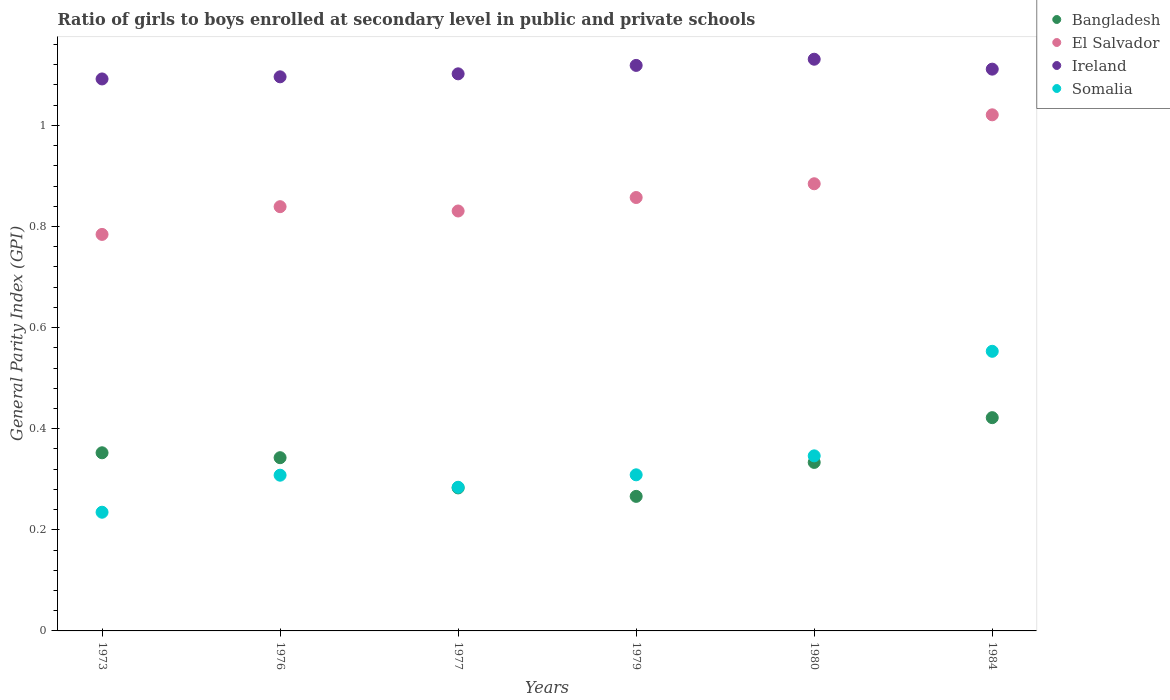Is the number of dotlines equal to the number of legend labels?
Your answer should be compact. Yes. What is the general parity index in El Salvador in 1973?
Your answer should be compact. 0.78. Across all years, what is the maximum general parity index in El Salvador?
Your answer should be compact. 1.02. Across all years, what is the minimum general parity index in Bangladesh?
Ensure brevity in your answer.  0.27. What is the total general parity index in Bangladesh in the graph?
Ensure brevity in your answer.  2. What is the difference between the general parity index in El Salvador in 1980 and that in 1984?
Your response must be concise. -0.14. What is the difference between the general parity index in Ireland in 1984 and the general parity index in Bangladesh in 1977?
Your response must be concise. 0.83. What is the average general parity index in Somalia per year?
Your answer should be compact. 0.34. In the year 1977, what is the difference between the general parity index in El Salvador and general parity index in Bangladesh?
Ensure brevity in your answer.  0.55. What is the ratio of the general parity index in Bangladesh in 1973 to that in 1980?
Ensure brevity in your answer.  1.06. Is the difference between the general parity index in El Salvador in 1980 and 1984 greater than the difference between the general parity index in Bangladesh in 1980 and 1984?
Provide a short and direct response. No. What is the difference between the highest and the second highest general parity index in Bangladesh?
Provide a succinct answer. 0.07. What is the difference between the highest and the lowest general parity index in Somalia?
Ensure brevity in your answer.  0.32. In how many years, is the general parity index in Somalia greater than the average general parity index in Somalia taken over all years?
Your answer should be very brief. 2. Is the sum of the general parity index in El Salvador in 1979 and 1980 greater than the maximum general parity index in Ireland across all years?
Your response must be concise. Yes. How many dotlines are there?
Offer a very short reply. 4. Does the graph contain grids?
Your answer should be very brief. No. How many legend labels are there?
Your response must be concise. 4. What is the title of the graph?
Your answer should be compact. Ratio of girls to boys enrolled at secondary level in public and private schools. What is the label or title of the Y-axis?
Give a very brief answer. General Parity Index (GPI). What is the General Parity Index (GPI) in Bangladesh in 1973?
Ensure brevity in your answer.  0.35. What is the General Parity Index (GPI) in El Salvador in 1973?
Provide a short and direct response. 0.78. What is the General Parity Index (GPI) of Ireland in 1973?
Your response must be concise. 1.09. What is the General Parity Index (GPI) in Somalia in 1973?
Keep it short and to the point. 0.23. What is the General Parity Index (GPI) in Bangladesh in 1976?
Keep it short and to the point. 0.34. What is the General Parity Index (GPI) of El Salvador in 1976?
Ensure brevity in your answer.  0.84. What is the General Parity Index (GPI) in Ireland in 1976?
Provide a succinct answer. 1.1. What is the General Parity Index (GPI) of Somalia in 1976?
Give a very brief answer. 0.31. What is the General Parity Index (GPI) of Bangladesh in 1977?
Make the answer very short. 0.28. What is the General Parity Index (GPI) of El Salvador in 1977?
Provide a succinct answer. 0.83. What is the General Parity Index (GPI) of Ireland in 1977?
Ensure brevity in your answer.  1.1. What is the General Parity Index (GPI) in Somalia in 1977?
Make the answer very short. 0.28. What is the General Parity Index (GPI) of Bangladesh in 1979?
Your answer should be very brief. 0.27. What is the General Parity Index (GPI) in El Salvador in 1979?
Your answer should be compact. 0.86. What is the General Parity Index (GPI) of Ireland in 1979?
Provide a succinct answer. 1.12. What is the General Parity Index (GPI) of Somalia in 1979?
Offer a very short reply. 0.31. What is the General Parity Index (GPI) in Bangladesh in 1980?
Give a very brief answer. 0.33. What is the General Parity Index (GPI) in El Salvador in 1980?
Provide a succinct answer. 0.88. What is the General Parity Index (GPI) of Ireland in 1980?
Offer a very short reply. 1.13. What is the General Parity Index (GPI) in Somalia in 1980?
Offer a terse response. 0.35. What is the General Parity Index (GPI) in Bangladesh in 1984?
Give a very brief answer. 0.42. What is the General Parity Index (GPI) of El Salvador in 1984?
Make the answer very short. 1.02. What is the General Parity Index (GPI) in Ireland in 1984?
Offer a terse response. 1.11. What is the General Parity Index (GPI) of Somalia in 1984?
Offer a terse response. 0.55. Across all years, what is the maximum General Parity Index (GPI) in Bangladesh?
Provide a short and direct response. 0.42. Across all years, what is the maximum General Parity Index (GPI) in El Salvador?
Ensure brevity in your answer.  1.02. Across all years, what is the maximum General Parity Index (GPI) of Ireland?
Give a very brief answer. 1.13. Across all years, what is the maximum General Parity Index (GPI) in Somalia?
Give a very brief answer. 0.55. Across all years, what is the minimum General Parity Index (GPI) of Bangladesh?
Make the answer very short. 0.27. Across all years, what is the minimum General Parity Index (GPI) in El Salvador?
Give a very brief answer. 0.78. Across all years, what is the minimum General Parity Index (GPI) in Ireland?
Offer a very short reply. 1.09. Across all years, what is the minimum General Parity Index (GPI) in Somalia?
Your answer should be very brief. 0.23. What is the total General Parity Index (GPI) in Bangladesh in the graph?
Give a very brief answer. 2. What is the total General Parity Index (GPI) of El Salvador in the graph?
Offer a very short reply. 5.22. What is the total General Parity Index (GPI) of Ireland in the graph?
Make the answer very short. 6.65. What is the total General Parity Index (GPI) of Somalia in the graph?
Provide a short and direct response. 2.04. What is the difference between the General Parity Index (GPI) of Bangladesh in 1973 and that in 1976?
Offer a terse response. 0.01. What is the difference between the General Parity Index (GPI) in El Salvador in 1973 and that in 1976?
Keep it short and to the point. -0.05. What is the difference between the General Parity Index (GPI) of Ireland in 1973 and that in 1976?
Keep it short and to the point. -0. What is the difference between the General Parity Index (GPI) of Somalia in 1973 and that in 1976?
Your answer should be very brief. -0.07. What is the difference between the General Parity Index (GPI) in Bangladesh in 1973 and that in 1977?
Your response must be concise. 0.07. What is the difference between the General Parity Index (GPI) in El Salvador in 1973 and that in 1977?
Your answer should be compact. -0.05. What is the difference between the General Parity Index (GPI) in Ireland in 1973 and that in 1977?
Your answer should be very brief. -0.01. What is the difference between the General Parity Index (GPI) of Somalia in 1973 and that in 1977?
Ensure brevity in your answer.  -0.05. What is the difference between the General Parity Index (GPI) of Bangladesh in 1973 and that in 1979?
Keep it short and to the point. 0.09. What is the difference between the General Parity Index (GPI) in El Salvador in 1973 and that in 1979?
Offer a terse response. -0.07. What is the difference between the General Parity Index (GPI) in Ireland in 1973 and that in 1979?
Make the answer very short. -0.03. What is the difference between the General Parity Index (GPI) in Somalia in 1973 and that in 1979?
Make the answer very short. -0.07. What is the difference between the General Parity Index (GPI) in Bangladesh in 1973 and that in 1980?
Make the answer very short. 0.02. What is the difference between the General Parity Index (GPI) in El Salvador in 1973 and that in 1980?
Keep it short and to the point. -0.1. What is the difference between the General Parity Index (GPI) of Ireland in 1973 and that in 1980?
Provide a short and direct response. -0.04. What is the difference between the General Parity Index (GPI) in Somalia in 1973 and that in 1980?
Offer a terse response. -0.11. What is the difference between the General Parity Index (GPI) in Bangladesh in 1973 and that in 1984?
Keep it short and to the point. -0.07. What is the difference between the General Parity Index (GPI) in El Salvador in 1973 and that in 1984?
Your response must be concise. -0.24. What is the difference between the General Parity Index (GPI) of Ireland in 1973 and that in 1984?
Offer a terse response. -0.02. What is the difference between the General Parity Index (GPI) in Somalia in 1973 and that in 1984?
Keep it short and to the point. -0.32. What is the difference between the General Parity Index (GPI) in Bangladesh in 1976 and that in 1977?
Make the answer very short. 0.06. What is the difference between the General Parity Index (GPI) of El Salvador in 1976 and that in 1977?
Give a very brief answer. 0.01. What is the difference between the General Parity Index (GPI) in Ireland in 1976 and that in 1977?
Provide a succinct answer. -0.01. What is the difference between the General Parity Index (GPI) in Somalia in 1976 and that in 1977?
Keep it short and to the point. 0.02. What is the difference between the General Parity Index (GPI) in Bangladesh in 1976 and that in 1979?
Offer a very short reply. 0.08. What is the difference between the General Parity Index (GPI) of El Salvador in 1976 and that in 1979?
Keep it short and to the point. -0.02. What is the difference between the General Parity Index (GPI) in Ireland in 1976 and that in 1979?
Provide a short and direct response. -0.02. What is the difference between the General Parity Index (GPI) of Somalia in 1976 and that in 1979?
Offer a terse response. -0. What is the difference between the General Parity Index (GPI) of Bangladesh in 1976 and that in 1980?
Your answer should be compact. 0.01. What is the difference between the General Parity Index (GPI) of El Salvador in 1976 and that in 1980?
Your response must be concise. -0.05. What is the difference between the General Parity Index (GPI) of Ireland in 1976 and that in 1980?
Make the answer very short. -0.03. What is the difference between the General Parity Index (GPI) in Somalia in 1976 and that in 1980?
Make the answer very short. -0.04. What is the difference between the General Parity Index (GPI) in Bangladesh in 1976 and that in 1984?
Make the answer very short. -0.08. What is the difference between the General Parity Index (GPI) of El Salvador in 1976 and that in 1984?
Your answer should be very brief. -0.18. What is the difference between the General Parity Index (GPI) of Ireland in 1976 and that in 1984?
Provide a short and direct response. -0.02. What is the difference between the General Parity Index (GPI) in Somalia in 1976 and that in 1984?
Your answer should be compact. -0.24. What is the difference between the General Parity Index (GPI) of Bangladesh in 1977 and that in 1979?
Your response must be concise. 0.02. What is the difference between the General Parity Index (GPI) in El Salvador in 1977 and that in 1979?
Provide a short and direct response. -0.03. What is the difference between the General Parity Index (GPI) of Ireland in 1977 and that in 1979?
Your answer should be very brief. -0.02. What is the difference between the General Parity Index (GPI) in Somalia in 1977 and that in 1979?
Provide a short and direct response. -0.02. What is the difference between the General Parity Index (GPI) in Bangladesh in 1977 and that in 1980?
Your answer should be compact. -0.05. What is the difference between the General Parity Index (GPI) in El Salvador in 1977 and that in 1980?
Offer a very short reply. -0.05. What is the difference between the General Parity Index (GPI) in Ireland in 1977 and that in 1980?
Offer a very short reply. -0.03. What is the difference between the General Parity Index (GPI) in Somalia in 1977 and that in 1980?
Give a very brief answer. -0.06. What is the difference between the General Parity Index (GPI) of Bangladesh in 1977 and that in 1984?
Offer a terse response. -0.14. What is the difference between the General Parity Index (GPI) of El Salvador in 1977 and that in 1984?
Ensure brevity in your answer.  -0.19. What is the difference between the General Parity Index (GPI) in Ireland in 1977 and that in 1984?
Your response must be concise. -0.01. What is the difference between the General Parity Index (GPI) of Somalia in 1977 and that in 1984?
Ensure brevity in your answer.  -0.27. What is the difference between the General Parity Index (GPI) of Bangladesh in 1979 and that in 1980?
Your answer should be very brief. -0.07. What is the difference between the General Parity Index (GPI) of El Salvador in 1979 and that in 1980?
Give a very brief answer. -0.03. What is the difference between the General Parity Index (GPI) in Ireland in 1979 and that in 1980?
Keep it short and to the point. -0.01. What is the difference between the General Parity Index (GPI) in Somalia in 1979 and that in 1980?
Your answer should be compact. -0.04. What is the difference between the General Parity Index (GPI) of Bangladesh in 1979 and that in 1984?
Your answer should be compact. -0.16. What is the difference between the General Parity Index (GPI) of El Salvador in 1979 and that in 1984?
Keep it short and to the point. -0.16. What is the difference between the General Parity Index (GPI) of Ireland in 1979 and that in 1984?
Offer a very short reply. 0.01. What is the difference between the General Parity Index (GPI) in Somalia in 1979 and that in 1984?
Give a very brief answer. -0.24. What is the difference between the General Parity Index (GPI) in Bangladesh in 1980 and that in 1984?
Make the answer very short. -0.09. What is the difference between the General Parity Index (GPI) in El Salvador in 1980 and that in 1984?
Provide a short and direct response. -0.14. What is the difference between the General Parity Index (GPI) in Ireland in 1980 and that in 1984?
Make the answer very short. 0.02. What is the difference between the General Parity Index (GPI) in Somalia in 1980 and that in 1984?
Ensure brevity in your answer.  -0.21. What is the difference between the General Parity Index (GPI) of Bangladesh in 1973 and the General Parity Index (GPI) of El Salvador in 1976?
Give a very brief answer. -0.49. What is the difference between the General Parity Index (GPI) of Bangladesh in 1973 and the General Parity Index (GPI) of Ireland in 1976?
Your answer should be compact. -0.74. What is the difference between the General Parity Index (GPI) of Bangladesh in 1973 and the General Parity Index (GPI) of Somalia in 1976?
Your answer should be very brief. 0.04. What is the difference between the General Parity Index (GPI) in El Salvador in 1973 and the General Parity Index (GPI) in Ireland in 1976?
Offer a very short reply. -0.31. What is the difference between the General Parity Index (GPI) of El Salvador in 1973 and the General Parity Index (GPI) of Somalia in 1976?
Ensure brevity in your answer.  0.48. What is the difference between the General Parity Index (GPI) in Ireland in 1973 and the General Parity Index (GPI) in Somalia in 1976?
Your answer should be very brief. 0.78. What is the difference between the General Parity Index (GPI) in Bangladesh in 1973 and the General Parity Index (GPI) in El Salvador in 1977?
Your answer should be very brief. -0.48. What is the difference between the General Parity Index (GPI) in Bangladesh in 1973 and the General Parity Index (GPI) in Ireland in 1977?
Give a very brief answer. -0.75. What is the difference between the General Parity Index (GPI) in Bangladesh in 1973 and the General Parity Index (GPI) in Somalia in 1977?
Your answer should be compact. 0.07. What is the difference between the General Parity Index (GPI) in El Salvador in 1973 and the General Parity Index (GPI) in Ireland in 1977?
Offer a very short reply. -0.32. What is the difference between the General Parity Index (GPI) in El Salvador in 1973 and the General Parity Index (GPI) in Somalia in 1977?
Your response must be concise. 0.5. What is the difference between the General Parity Index (GPI) of Ireland in 1973 and the General Parity Index (GPI) of Somalia in 1977?
Ensure brevity in your answer.  0.81. What is the difference between the General Parity Index (GPI) of Bangladesh in 1973 and the General Parity Index (GPI) of El Salvador in 1979?
Make the answer very short. -0.5. What is the difference between the General Parity Index (GPI) of Bangladesh in 1973 and the General Parity Index (GPI) of Ireland in 1979?
Ensure brevity in your answer.  -0.77. What is the difference between the General Parity Index (GPI) in Bangladesh in 1973 and the General Parity Index (GPI) in Somalia in 1979?
Your answer should be compact. 0.04. What is the difference between the General Parity Index (GPI) in El Salvador in 1973 and the General Parity Index (GPI) in Ireland in 1979?
Provide a succinct answer. -0.33. What is the difference between the General Parity Index (GPI) of El Salvador in 1973 and the General Parity Index (GPI) of Somalia in 1979?
Offer a very short reply. 0.48. What is the difference between the General Parity Index (GPI) of Ireland in 1973 and the General Parity Index (GPI) of Somalia in 1979?
Keep it short and to the point. 0.78. What is the difference between the General Parity Index (GPI) in Bangladesh in 1973 and the General Parity Index (GPI) in El Salvador in 1980?
Offer a terse response. -0.53. What is the difference between the General Parity Index (GPI) in Bangladesh in 1973 and the General Parity Index (GPI) in Ireland in 1980?
Ensure brevity in your answer.  -0.78. What is the difference between the General Parity Index (GPI) of Bangladesh in 1973 and the General Parity Index (GPI) of Somalia in 1980?
Make the answer very short. 0.01. What is the difference between the General Parity Index (GPI) in El Salvador in 1973 and the General Parity Index (GPI) in Ireland in 1980?
Provide a succinct answer. -0.35. What is the difference between the General Parity Index (GPI) of El Salvador in 1973 and the General Parity Index (GPI) of Somalia in 1980?
Make the answer very short. 0.44. What is the difference between the General Parity Index (GPI) in Ireland in 1973 and the General Parity Index (GPI) in Somalia in 1980?
Your answer should be very brief. 0.75. What is the difference between the General Parity Index (GPI) of Bangladesh in 1973 and the General Parity Index (GPI) of El Salvador in 1984?
Ensure brevity in your answer.  -0.67. What is the difference between the General Parity Index (GPI) in Bangladesh in 1973 and the General Parity Index (GPI) in Ireland in 1984?
Your response must be concise. -0.76. What is the difference between the General Parity Index (GPI) in Bangladesh in 1973 and the General Parity Index (GPI) in Somalia in 1984?
Offer a very short reply. -0.2. What is the difference between the General Parity Index (GPI) of El Salvador in 1973 and the General Parity Index (GPI) of Ireland in 1984?
Your answer should be very brief. -0.33. What is the difference between the General Parity Index (GPI) of El Salvador in 1973 and the General Parity Index (GPI) of Somalia in 1984?
Ensure brevity in your answer.  0.23. What is the difference between the General Parity Index (GPI) of Ireland in 1973 and the General Parity Index (GPI) of Somalia in 1984?
Provide a succinct answer. 0.54. What is the difference between the General Parity Index (GPI) of Bangladesh in 1976 and the General Parity Index (GPI) of El Salvador in 1977?
Ensure brevity in your answer.  -0.49. What is the difference between the General Parity Index (GPI) of Bangladesh in 1976 and the General Parity Index (GPI) of Ireland in 1977?
Your answer should be compact. -0.76. What is the difference between the General Parity Index (GPI) in Bangladesh in 1976 and the General Parity Index (GPI) in Somalia in 1977?
Provide a short and direct response. 0.06. What is the difference between the General Parity Index (GPI) of El Salvador in 1976 and the General Parity Index (GPI) of Ireland in 1977?
Offer a very short reply. -0.26. What is the difference between the General Parity Index (GPI) of El Salvador in 1976 and the General Parity Index (GPI) of Somalia in 1977?
Keep it short and to the point. 0.56. What is the difference between the General Parity Index (GPI) in Ireland in 1976 and the General Parity Index (GPI) in Somalia in 1977?
Make the answer very short. 0.81. What is the difference between the General Parity Index (GPI) in Bangladesh in 1976 and the General Parity Index (GPI) in El Salvador in 1979?
Give a very brief answer. -0.51. What is the difference between the General Parity Index (GPI) of Bangladesh in 1976 and the General Parity Index (GPI) of Ireland in 1979?
Give a very brief answer. -0.78. What is the difference between the General Parity Index (GPI) in Bangladesh in 1976 and the General Parity Index (GPI) in Somalia in 1979?
Ensure brevity in your answer.  0.03. What is the difference between the General Parity Index (GPI) in El Salvador in 1976 and the General Parity Index (GPI) in Ireland in 1979?
Ensure brevity in your answer.  -0.28. What is the difference between the General Parity Index (GPI) in El Salvador in 1976 and the General Parity Index (GPI) in Somalia in 1979?
Offer a very short reply. 0.53. What is the difference between the General Parity Index (GPI) in Ireland in 1976 and the General Parity Index (GPI) in Somalia in 1979?
Make the answer very short. 0.79. What is the difference between the General Parity Index (GPI) in Bangladesh in 1976 and the General Parity Index (GPI) in El Salvador in 1980?
Your response must be concise. -0.54. What is the difference between the General Parity Index (GPI) in Bangladesh in 1976 and the General Parity Index (GPI) in Ireland in 1980?
Offer a very short reply. -0.79. What is the difference between the General Parity Index (GPI) of Bangladesh in 1976 and the General Parity Index (GPI) of Somalia in 1980?
Give a very brief answer. -0. What is the difference between the General Parity Index (GPI) of El Salvador in 1976 and the General Parity Index (GPI) of Ireland in 1980?
Make the answer very short. -0.29. What is the difference between the General Parity Index (GPI) in El Salvador in 1976 and the General Parity Index (GPI) in Somalia in 1980?
Make the answer very short. 0.49. What is the difference between the General Parity Index (GPI) in Ireland in 1976 and the General Parity Index (GPI) in Somalia in 1980?
Your response must be concise. 0.75. What is the difference between the General Parity Index (GPI) in Bangladesh in 1976 and the General Parity Index (GPI) in El Salvador in 1984?
Provide a succinct answer. -0.68. What is the difference between the General Parity Index (GPI) of Bangladesh in 1976 and the General Parity Index (GPI) of Ireland in 1984?
Provide a short and direct response. -0.77. What is the difference between the General Parity Index (GPI) of Bangladesh in 1976 and the General Parity Index (GPI) of Somalia in 1984?
Offer a terse response. -0.21. What is the difference between the General Parity Index (GPI) of El Salvador in 1976 and the General Parity Index (GPI) of Ireland in 1984?
Your answer should be very brief. -0.27. What is the difference between the General Parity Index (GPI) in El Salvador in 1976 and the General Parity Index (GPI) in Somalia in 1984?
Offer a very short reply. 0.29. What is the difference between the General Parity Index (GPI) of Ireland in 1976 and the General Parity Index (GPI) of Somalia in 1984?
Your answer should be compact. 0.54. What is the difference between the General Parity Index (GPI) in Bangladesh in 1977 and the General Parity Index (GPI) in El Salvador in 1979?
Your response must be concise. -0.57. What is the difference between the General Parity Index (GPI) in Bangladesh in 1977 and the General Parity Index (GPI) in Ireland in 1979?
Your answer should be very brief. -0.84. What is the difference between the General Parity Index (GPI) in Bangladesh in 1977 and the General Parity Index (GPI) in Somalia in 1979?
Ensure brevity in your answer.  -0.03. What is the difference between the General Parity Index (GPI) in El Salvador in 1977 and the General Parity Index (GPI) in Ireland in 1979?
Make the answer very short. -0.29. What is the difference between the General Parity Index (GPI) in El Salvador in 1977 and the General Parity Index (GPI) in Somalia in 1979?
Give a very brief answer. 0.52. What is the difference between the General Parity Index (GPI) of Ireland in 1977 and the General Parity Index (GPI) of Somalia in 1979?
Make the answer very short. 0.79. What is the difference between the General Parity Index (GPI) of Bangladesh in 1977 and the General Parity Index (GPI) of El Salvador in 1980?
Keep it short and to the point. -0.6. What is the difference between the General Parity Index (GPI) in Bangladesh in 1977 and the General Parity Index (GPI) in Ireland in 1980?
Provide a short and direct response. -0.85. What is the difference between the General Parity Index (GPI) of Bangladesh in 1977 and the General Parity Index (GPI) of Somalia in 1980?
Your answer should be very brief. -0.06. What is the difference between the General Parity Index (GPI) in El Salvador in 1977 and the General Parity Index (GPI) in Ireland in 1980?
Your answer should be compact. -0.3. What is the difference between the General Parity Index (GPI) in El Salvador in 1977 and the General Parity Index (GPI) in Somalia in 1980?
Offer a terse response. 0.48. What is the difference between the General Parity Index (GPI) in Ireland in 1977 and the General Parity Index (GPI) in Somalia in 1980?
Offer a very short reply. 0.76. What is the difference between the General Parity Index (GPI) of Bangladesh in 1977 and the General Parity Index (GPI) of El Salvador in 1984?
Offer a terse response. -0.74. What is the difference between the General Parity Index (GPI) of Bangladesh in 1977 and the General Parity Index (GPI) of Ireland in 1984?
Your response must be concise. -0.83. What is the difference between the General Parity Index (GPI) in Bangladesh in 1977 and the General Parity Index (GPI) in Somalia in 1984?
Offer a terse response. -0.27. What is the difference between the General Parity Index (GPI) of El Salvador in 1977 and the General Parity Index (GPI) of Ireland in 1984?
Make the answer very short. -0.28. What is the difference between the General Parity Index (GPI) in El Salvador in 1977 and the General Parity Index (GPI) in Somalia in 1984?
Your response must be concise. 0.28. What is the difference between the General Parity Index (GPI) of Ireland in 1977 and the General Parity Index (GPI) of Somalia in 1984?
Offer a very short reply. 0.55. What is the difference between the General Parity Index (GPI) in Bangladesh in 1979 and the General Parity Index (GPI) in El Salvador in 1980?
Make the answer very short. -0.62. What is the difference between the General Parity Index (GPI) in Bangladesh in 1979 and the General Parity Index (GPI) in Ireland in 1980?
Provide a short and direct response. -0.86. What is the difference between the General Parity Index (GPI) in Bangladesh in 1979 and the General Parity Index (GPI) in Somalia in 1980?
Offer a terse response. -0.08. What is the difference between the General Parity Index (GPI) of El Salvador in 1979 and the General Parity Index (GPI) of Ireland in 1980?
Your answer should be very brief. -0.27. What is the difference between the General Parity Index (GPI) of El Salvador in 1979 and the General Parity Index (GPI) of Somalia in 1980?
Give a very brief answer. 0.51. What is the difference between the General Parity Index (GPI) in Ireland in 1979 and the General Parity Index (GPI) in Somalia in 1980?
Make the answer very short. 0.77. What is the difference between the General Parity Index (GPI) of Bangladesh in 1979 and the General Parity Index (GPI) of El Salvador in 1984?
Your response must be concise. -0.75. What is the difference between the General Parity Index (GPI) of Bangladesh in 1979 and the General Parity Index (GPI) of Ireland in 1984?
Provide a short and direct response. -0.84. What is the difference between the General Parity Index (GPI) of Bangladesh in 1979 and the General Parity Index (GPI) of Somalia in 1984?
Give a very brief answer. -0.29. What is the difference between the General Parity Index (GPI) in El Salvador in 1979 and the General Parity Index (GPI) in Ireland in 1984?
Your answer should be very brief. -0.25. What is the difference between the General Parity Index (GPI) in El Salvador in 1979 and the General Parity Index (GPI) in Somalia in 1984?
Provide a short and direct response. 0.3. What is the difference between the General Parity Index (GPI) in Ireland in 1979 and the General Parity Index (GPI) in Somalia in 1984?
Make the answer very short. 0.57. What is the difference between the General Parity Index (GPI) in Bangladesh in 1980 and the General Parity Index (GPI) in El Salvador in 1984?
Your response must be concise. -0.69. What is the difference between the General Parity Index (GPI) in Bangladesh in 1980 and the General Parity Index (GPI) in Ireland in 1984?
Your response must be concise. -0.78. What is the difference between the General Parity Index (GPI) of Bangladesh in 1980 and the General Parity Index (GPI) of Somalia in 1984?
Your answer should be compact. -0.22. What is the difference between the General Parity Index (GPI) in El Salvador in 1980 and the General Parity Index (GPI) in Ireland in 1984?
Your response must be concise. -0.23. What is the difference between the General Parity Index (GPI) of El Salvador in 1980 and the General Parity Index (GPI) of Somalia in 1984?
Give a very brief answer. 0.33. What is the difference between the General Parity Index (GPI) of Ireland in 1980 and the General Parity Index (GPI) of Somalia in 1984?
Make the answer very short. 0.58. What is the average General Parity Index (GPI) of Bangladesh per year?
Give a very brief answer. 0.33. What is the average General Parity Index (GPI) of El Salvador per year?
Your answer should be very brief. 0.87. What is the average General Parity Index (GPI) of Ireland per year?
Make the answer very short. 1.11. What is the average General Parity Index (GPI) of Somalia per year?
Your answer should be compact. 0.34. In the year 1973, what is the difference between the General Parity Index (GPI) of Bangladesh and General Parity Index (GPI) of El Salvador?
Keep it short and to the point. -0.43. In the year 1973, what is the difference between the General Parity Index (GPI) of Bangladesh and General Parity Index (GPI) of Ireland?
Make the answer very short. -0.74. In the year 1973, what is the difference between the General Parity Index (GPI) in Bangladesh and General Parity Index (GPI) in Somalia?
Offer a terse response. 0.12. In the year 1973, what is the difference between the General Parity Index (GPI) of El Salvador and General Parity Index (GPI) of Ireland?
Your response must be concise. -0.31. In the year 1973, what is the difference between the General Parity Index (GPI) in El Salvador and General Parity Index (GPI) in Somalia?
Keep it short and to the point. 0.55. In the year 1973, what is the difference between the General Parity Index (GPI) in Ireland and General Parity Index (GPI) in Somalia?
Give a very brief answer. 0.86. In the year 1976, what is the difference between the General Parity Index (GPI) of Bangladesh and General Parity Index (GPI) of El Salvador?
Your answer should be compact. -0.5. In the year 1976, what is the difference between the General Parity Index (GPI) of Bangladesh and General Parity Index (GPI) of Ireland?
Ensure brevity in your answer.  -0.75. In the year 1976, what is the difference between the General Parity Index (GPI) in Bangladesh and General Parity Index (GPI) in Somalia?
Keep it short and to the point. 0.03. In the year 1976, what is the difference between the General Parity Index (GPI) of El Salvador and General Parity Index (GPI) of Ireland?
Your answer should be very brief. -0.26. In the year 1976, what is the difference between the General Parity Index (GPI) in El Salvador and General Parity Index (GPI) in Somalia?
Your answer should be compact. 0.53. In the year 1976, what is the difference between the General Parity Index (GPI) of Ireland and General Parity Index (GPI) of Somalia?
Make the answer very short. 0.79. In the year 1977, what is the difference between the General Parity Index (GPI) in Bangladesh and General Parity Index (GPI) in El Salvador?
Your answer should be compact. -0.55. In the year 1977, what is the difference between the General Parity Index (GPI) of Bangladesh and General Parity Index (GPI) of Ireland?
Keep it short and to the point. -0.82. In the year 1977, what is the difference between the General Parity Index (GPI) of Bangladesh and General Parity Index (GPI) of Somalia?
Your answer should be very brief. -0. In the year 1977, what is the difference between the General Parity Index (GPI) of El Salvador and General Parity Index (GPI) of Ireland?
Offer a terse response. -0.27. In the year 1977, what is the difference between the General Parity Index (GPI) of El Salvador and General Parity Index (GPI) of Somalia?
Give a very brief answer. 0.55. In the year 1977, what is the difference between the General Parity Index (GPI) in Ireland and General Parity Index (GPI) in Somalia?
Make the answer very short. 0.82. In the year 1979, what is the difference between the General Parity Index (GPI) in Bangladesh and General Parity Index (GPI) in El Salvador?
Your response must be concise. -0.59. In the year 1979, what is the difference between the General Parity Index (GPI) in Bangladesh and General Parity Index (GPI) in Ireland?
Make the answer very short. -0.85. In the year 1979, what is the difference between the General Parity Index (GPI) in Bangladesh and General Parity Index (GPI) in Somalia?
Keep it short and to the point. -0.04. In the year 1979, what is the difference between the General Parity Index (GPI) in El Salvador and General Parity Index (GPI) in Ireland?
Your answer should be compact. -0.26. In the year 1979, what is the difference between the General Parity Index (GPI) of El Salvador and General Parity Index (GPI) of Somalia?
Provide a succinct answer. 0.55. In the year 1979, what is the difference between the General Parity Index (GPI) of Ireland and General Parity Index (GPI) of Somalia?
Offer a terse response. 0.81. In the year 1980, what is the difference between the General Parity Index (GPI) of Bangladesh and General Parity Index (GPI) of El Salvador?
Make the answer very short. -0.55. In the year 1980, what is the difference between the General Parity Index (GPI) of Bangladesh and General Parity Index (GPI) of Ireland?
Your response must be concise. -0.8. In the year 1980, what is the difference between the General Parity Index (GPI) in Bangladesh and General Parity Index (GPI) in Somalia?
Your response must be concise. -0.01. In the year 1980, what is the difference between the General Parity Index (GPI) in El Salvador and General Parity Index (GPI) in Ireland?
Make the answer very short. -0.25. In the year 1980, what is the difference between the General Parity Index (GPI) in El Salvador and General Parity Index (GPI) in Somalia?
Offer a very short reply. 0.54. In the year 1980, what is the difference between the General Parity Index (GPI) of Ireland and General Parity Index (GPI) of Somalia?
Give a very brief answer. 0.78. In the year 1984, what is the difference between the General Parity Index (GPI) in Bangladesh and General Parity Index (GPI) in El Salvador?
Your answer should be very brief. -0.6. In the year 1984, what is the difference between the General Parity Index (GPI) in Bangladesh and General Parity Index (GPI) in Ireland?
Ensure brevity in your answer.  -0.69. In the year 1984, what is the difference between the General Parity Index (GPI) in Bangladesh and General Parity Index (GPI) in Somalia?
Provide a succinct answer. -0.13. In the year 1984, what is the difference between the General Parity Index (GPI) in El Salvador and General Parity Index (GPI) in Ireland?
Offer a very short reply. -0.09. In the year 1984, what is the difference between the General Parity Index (GPI) in El Salvador and General Parity Index (GPI) in Somalia?
Your response must be concise. 0.47. In the year 1984, what is the difference between the General Parity Index (GPI) in Ireland and General Parity Index (GPI) in Somalia?
Your answer should be very brief. 0.56. What is the ratio of the General Parity Index (GPI) of Bangladesh in 1973 to that in 1976?
Keep it short and to the point. 1.03. What is the ratio of the General Parity Index (GPI) in El Salvador in 1973 to that in 1976?
Your answer should be compact. 0.93. What is the ratio of the General Parity Index (GPI) of Somalia in 1973 to that in 1976?
Provide a succinct answer. 0.76. What is the ratio of the General Parity Index (GPI) in Bangladesh in 1973 to that in 1977?
Ensure brevity in your answer.  1.25. What is the ratio of the General Parity Index (GPI) in El Salvador in 1973 to that in 1977?
Keep it short and to the point. 0.94. What is the ratio of the General Parity Index (GPI) of Somalia in 1973 to that in 1977?
Your answer should be very brief. 0.83. What is the ratio of the General Parity Index (GPI) in Bangladesh in 1973 to that in 1979?
Offer a terse response. 1.32. What is the ratio of the General Parity Index (GPI) in El Salvador in 1973 to that in 1979?
Ensure brevity in your answer.  0.91. What is the ratio of the General Parity Index (GPI) in Ireland in 1973 to that in 1979?
Offer a very short reply. 0.98. What is the ratio of the General Parity Index (GPI) in Somalia in 1973 to that in 1979?
Your response must be concise. 0.76. What is the ratio of the General Parity Index (GPI) in Bangladesh in 1973 to that in 1980?
Provide a succinct answer. 1.06. What is the ratio of the General Parity Index (GPI) of El Salvador in 1973 to that in 1980?
Make the answer very short. 0.89. What is the ratio of the General Parity Index (GPI) of Ireland in 1973 to that in 1980?
Make the answer very short. 0.97. What is the ratio of the General Parity Index (GPI) in Somalia in 1973 to that in 1980?
Your answer should be compact. 0.68. What is the ratio of the General Parity Index (GPI) of Bangladesh in 1973 to that in 1984?
Your answer should be very brief. 0.84. What is the ratio of the General Parity Index (GPI) of El Salvador in 1973 to that in 1984?
Your answer should be very brief. 0.77. What is the ratio of the General Parity Index (GPI) of Ireland in 1973 to that in 1984?
Your answer should be very brief. 0.98. What is the ratio of the General Parity Index (GPI) of Somalia in 1973 to that in 1984?
Provide a short and direct response. 0.42. What is the ratio of the General Parity Index (GPI) in Bangladesh in 1976 to that in 1977?
Ensure brevity in your answer.  1.21. What is the ratio of the General Parity Index (GPI) of El Salvador in 1976 to that in 1977?
Offer a terse response. 1.01. What is the ratio of the General Parity Index (GPI) of Somalia in 1976 to that in 1977?
Your answer should be very brief. 1.08. What is the ratio of the General Parity Index (GPI) in Bangladesh in 1976 to that in 1979?
Your response must be concise. 1.29. What is the ratio of the General Parity Index (GPI) of El Salvador in 1976 to that in 1979?
Your answer should be very brief. 0.98. What is the ratio of the General Parity Index (GPI) of Ireland in 1976 to that in 1979?
Ensure brevity in your answer.  0.98. What is the ratio of the General Parity Index (GPI) of Somalia in 1976 to that in 1979?
Make the answer very short. 1. What is the ratio of the General Parity Index (GPI) of Bangladesh in 1976 to that in 1980?
Provide a succinct answer. 1.03. What is the ratio of the General Parity Index (GPI) in El Salvador in 1976 to that in 1980?
Make the answer very short. 0.95. What is the ratio of the General Parity Index (GPI) of Ireland in 1976 to that in 1980?
Ensure brevity in your answer.  0.97. What is the ratio of the General Parity Index (GPI) in Somalia in 1976 to that in 1980?
Your response must be concise. 0.89. What is the ratio of the General Parity Index (GPI) in Bangladesh in 1976 to that in 1984?
Your answer should be compact. 0.81. What is the ratio of the General Parity Index (GPI) in El Salvador in 1976 to that in 1984?
Offer a very short reply. 0.82. What is the ratio of the General Parity Index (GPI) of Ireland in 1976 to that in 1984?
Keep it short and to the point. 0.99. What is the ratio of the General Parity Index (GPI) of Somalia in 1976 to that in 1984?
Your answer should be compact. 0.56. What is the ratio of the General Parity Index (GPI) of Bangladesh in 1977 to that in 1979?
Your answer should be compact. 1.06. What is the ratio of the General Parity Index (GPI) of El Salvador in 1977 to that in 1979?
Your answer should be very brief. 0.97. What is the ratio of the General Parity Index (GPI) in Ireland in 1977 to that in 1979?
Offer a very short reply. 0.99. What is the ratio of the General Parity Index (GPI) of Somalia in 1977 to that in 1979?
Give a very brief answer. 0.92. What is the ratio of the General Parity Index (GPI) in Bangladesh in 1977 to that in 1980?
Ensure brevity in your answer.  0.85. What is the ratio of the General Parity Index (GPI) of El Salvador in 1977 to that in 1980?
Make the answer very short. 0.94. What is the ratio of the General Parity Index (GPI) of Ireland in 1977 to that in 1980?
Your answer should be compact. 0.97. What is the ratio of the General Parity Index (GPI) in Somalia in 1977 to that in 1980?
Make the answer very short. 0.82. What is the ratio of the General Parity Index (GPI) of Bangladesh in 1977 to that in 1984?
Provide a short and direct response. 0.67. What is the ratio of the General Parity Index (GPI) of El Salvador in 1977 to that in 1984?
Provide a succinct answer. 0.81. What is the ratio of the General Parity Index (GPI) of Somalia in 1977 to that in 1984?
Give a very brief answer. 0.51. What is the ratio of the General Parity Index (GPI) of Bangladesh in 1979 to that in 1980?
Your answer should be compact. 0.8. What is the ratio of the General Parity Index (GPI) of El Salvador in 1979 to that in 1980?
Offer a terse response. 0.97. What is the ratio of the General Parity Index (GPI) in Ireland in 1979 to that in 1980?
Keep it short and to the point. 0.99. What is the ratio of the General Parity Index (GPI) of Somalia in 1979 to that in 1980?
Provide a succinct answer. 0.89. What is the ratio of the General Parity Index (GPI) of Bangladesh in 1979 to that in 1984?
Ensure brevity in your answer.  0.63. What is the ratio of the General Parity Index (GPI) of El Salvador in 1979 to that in 1984?
Provide a succinct answer. 0.84. What is the ratio of the General Parity Index (GPI) of Somalia in 1979 to that in 1984?
Your answer should be compact. 0.56. What is the ratio of the General Parity Index (GPI) in Bangladesh in 1980 to that in 1984?
Your answer should be very brief. 0.79. What is the ratio of the General Parity Index (GPI) of El Salvador in 1980 to that in 1984?
Make the answer very short. 0.87. What is the ratio of the General Parity Index (GPI) in Ireland in 1980 to that in 1984?
Your answer should be compact. 1.02. What is the ratio of the General Parity Index (GPI) in Somalia in 1980 to that in 1984?
Provide a succinct answer. 0.63. What is the difference between the highest and the second highest General Parity Index (GPI) in Bangladesh?
Your answer should be compact. 0.07. What is the difference between the highest and the second highest General Parity Index (GPI) in El Salvador?
Ensure brevity in your answer.  0.14. What is the difference between the highest and the second highest General Parity Index (GPI) in Ireland?
Your answer should be very brief. 0.01. What is the difference between the highest and the second highest General Parity Index (GPI) of Somalia?
Provide a short and direct response. 0.21. What is the difference between the highest and the lowest General Parity Index (GPI) of Bangladesh?
Offer a terse response. 0.16. What is the difference between the highest and the lowest General Parity Index (GPI) of El Salvador?
Your response must be concise. 0.24. What is the difference between the highest and the lowest General Parity Index (GPI) of Ireland?
Ensure brevity in your answer.  0.04. What is the difference between the highest and the lowest General Parity Index (GPI) in Somalia?
Give a very brief answer. 0.32. 